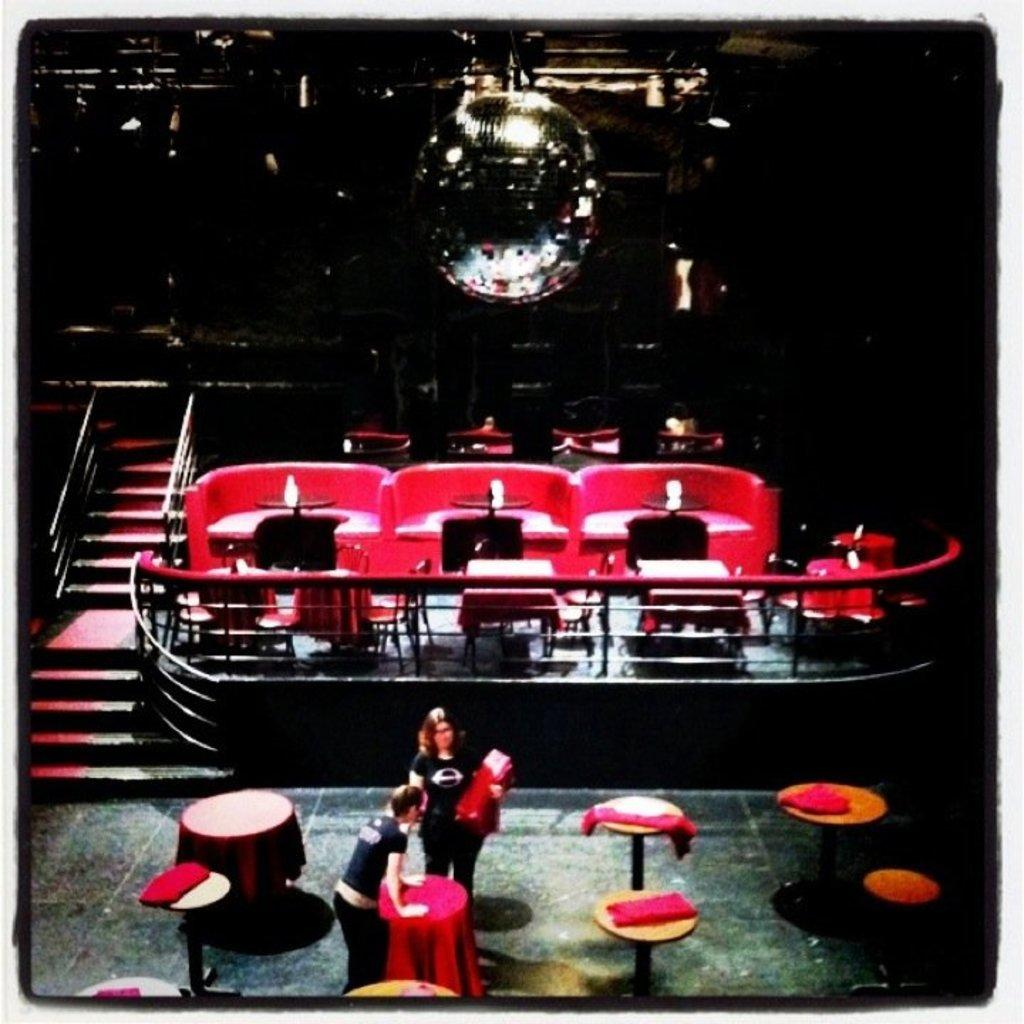What type of furniture is present in the image? There are tables in the image. What architectural feature is visible in the image? There are stairs in the image. What safety feature is present in the image? There are railings in the image. Can you describe the people in the image? There are people standing in the image. How would you describe the lighting in the image? The image appears to be slightly dark. What type of button is being pushed by the arm of the father in the image? There is no father or button present in the image. What type of arm is visible in the image? There is no arm visible in the image. 